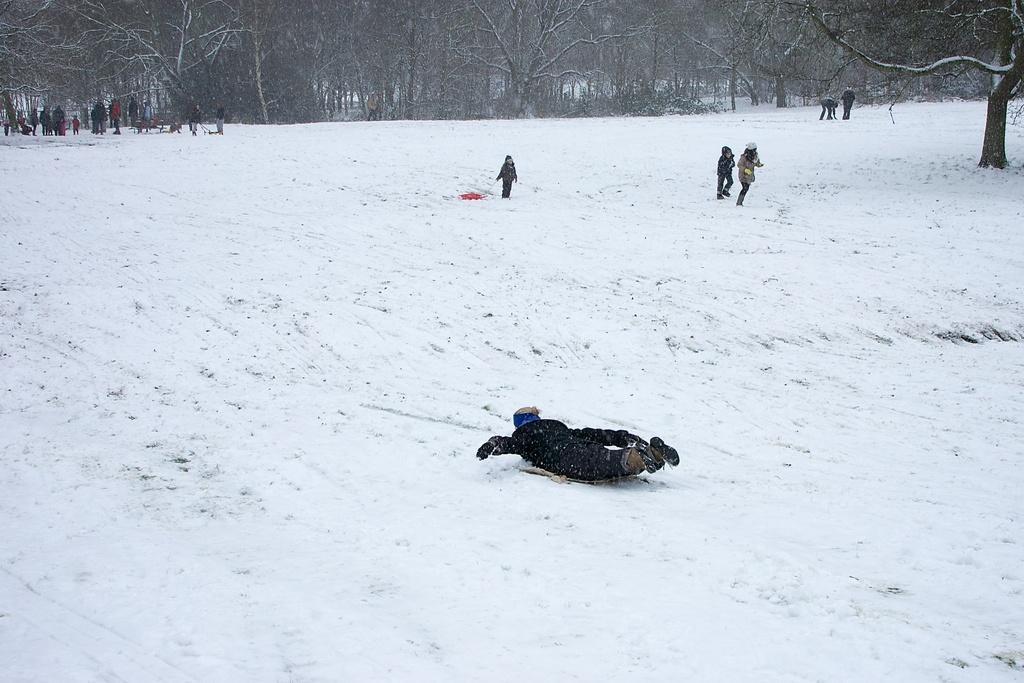Could you give a brief overview of what you see in this image? In this image I can see the snow on the ground and a person wearing black color dress is lying. In the background I can see number of persons are standing, few trees and some snow on the trees. 